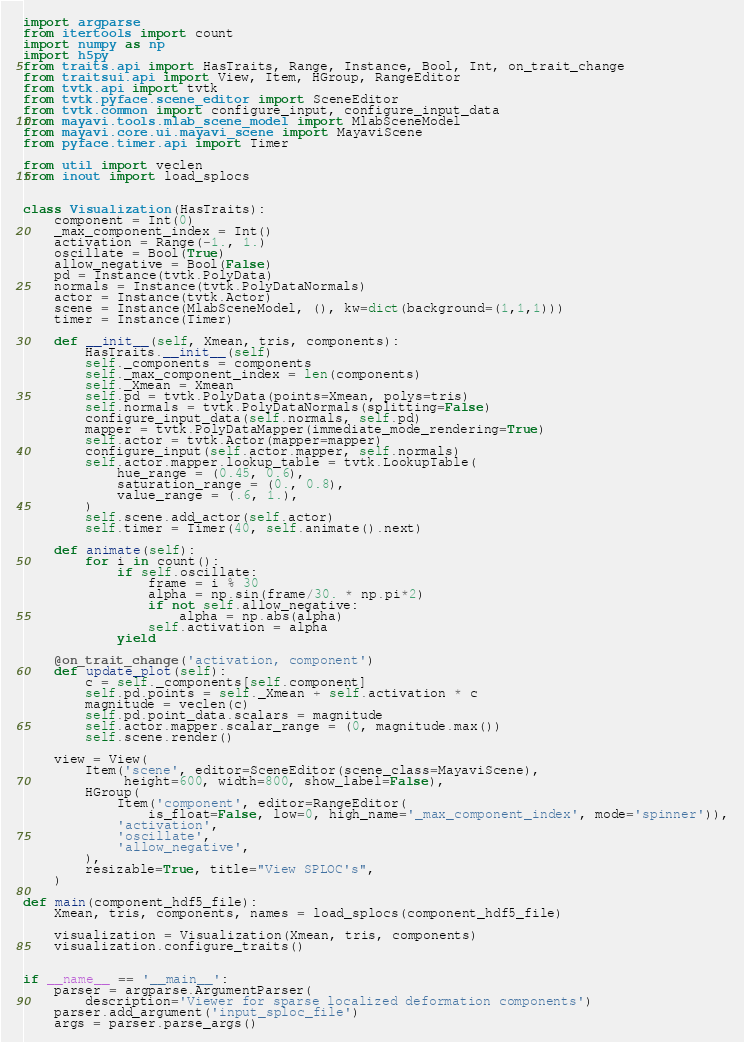<code> <loc_0><loc_0><loc_500><loc_500><_Python_>import argparse
from itertools import count
import numpy as np
import h5py
from traits.api import HasTraits, Range, Instance, Bool, Int, on_trait_change
from traitsui.api import View, Item, HGroup, RangeEditor
from tvtk.api import tvtk
from tvtk.pyface.scene_editor import SceneEditor
from tvtk.common import configure_input, configure_input_data
from mayavi.tools.mlab_scene_model import MlabSceneModel
from mayavi.core.ui.mayavi_scene import MayaviScene
from pyface.timer.api import Timer

from util import veclen
from inout import load_splocs


class Visualization(HasTraits):
    component = Int(0)
    _max_component_index = Int()
    activation = Range(-1., 1.)
    oscillate = Bool(True)
    allow_negative = Bool(False)
    pd = Instance(tvtk.PolyData)
    normals = Instance(tvtk.PolyDataNormals)
    actor = Instance(tvtk.Actor)
    scene = Instance(MlabSceneModel, (), kw=dict(background=(1,1,1)))
    timer = Instance(Timer)

    def __init__(self, Xmean, tris, components):
        HasTraits.__init__(self)
        self._components = components
        self._max_component_index = len(components)
        self._Xmean = Xmean
        self.pd = tvtk.PolyData(points=Xmean, polys=tris)
        self.normals = tvtk.PolyDataNormals(splitting=False)
        configure_input_data(self.normals, self.pd)
        mapper = tvtk.PolyDataMapper(immediate_mode_rendering=True)
        self.actor = tvtk.Actor(mapper=mapper)
        configure_input(self.actor.mapper, self.normals)
        self.actor.mapper.lookup_table = tvtk.LookupTable(
            hue_range = (0.45, 0.6),
            saturation_range = (0., 0.8),
            value_range = (.6, 1.),
        )
        self.scene.add_actor(self.actor)
        self.timer = Timer(40, self.animate().next)

    def animate(self):
        for i in count():
            if self.oscillate:
                frame = i % 30
                alpha = np.sin(frame/30. * np.pi*2)
                if not self.allow_negative:
                    alpha = np.abs(alpha)
                self.activation = alpha
            yield

    @on_trait_change('activation, component')
    def update_plot(self):
        c = self._components[self.component]
        self.pd.points = self._Xmean + self.activation * c
        magnitude = veclen(c)
        self.pd.point_data.scalars = magnitude
        self.actor.mapper.scalar_range = (0, magnitude.max())
        self.scene.render()

    view = View(
        Item('scene', editor=SceneEditor(scene_class=MayaviScene),
             height=600, width=800, show_label=False),
        HGroup(
            Item('component', editor=RangeEditor(
                is_float=False, low=0, high_name='_max_component_index', mode='spinner')),
            'activation', 
            'oscillate', 
            'allow_negative',
        ),
        resizable=True, title="View SPLOC's",
    )

def main(component_hdf5_file):
    Xmean, tris, components, names = load_splocs(component_hdf5_file)

    visualization = Visualization(Xmean, tris, components)
    visualization.configure_traits()


if __name__ == '__main__':
    parser = argparse.ArgumentParser(
        description='Viewer for sparse localized deformation components')
    parser.add_argument('input_sploc_file')
    args = parser.parse_args()</code> 